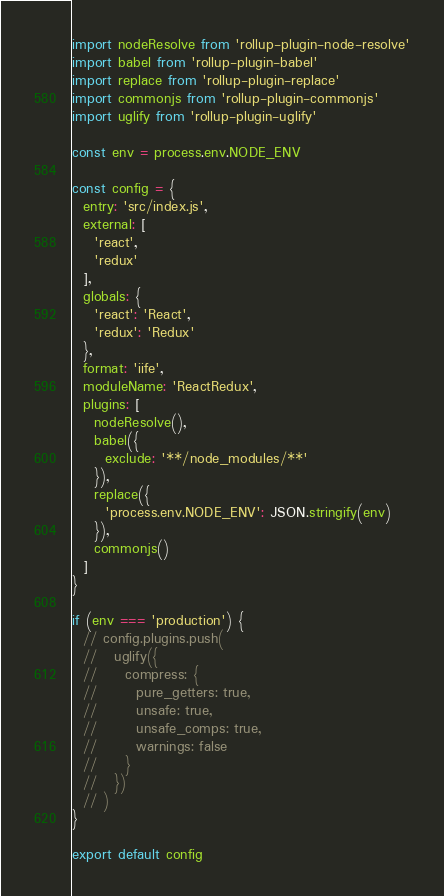Convert code to text. <code><loc_0><loc_0><loc_500><loc_500><_JavaScript_>import nodeResolve from 'rollup-plugin-node-resolve'
import babel from 'rollup-plugin-babel'
import replace from 'rollup-plugin-replace'
import commonjs from 'rollup-plugin-commonjs'
import uglify from 'rollup-plugin-uglify'

const env = process.env.NODE_ENV

const config = {
  entry: 'src/index.js',
  external: [
    'react',
    'redux'
  ],
  globals: {
    'react': 'React',
    'redux': 'Redux'
  },
  format: 'iife',
  moduleName: 'ReactRedux',
  plugins: [
    nodeResolve(),
    babel({
      exclude: '**/node_modules/**'
    }),
    replace({
      'process.env.NODE_ENV': JSON.stringify(env)
    }),
    commonjs()
  ]
}

if (env === 'production') {
  // config.plugins.push(
  //   uglify({
  //     compress: {
  //       pure_getters: true,
  //       unsafe: true,
  //       unsafe_comps: true,
  //       warnings: false
  //     }
  //   })
  // )
}

export default config
</code> 